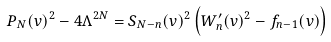<formula> <loc_0><loc_0><loc_500><loc_500>P _ { N } ( v ) ^ { 2 } - 4 \Lambda ^ { 2 N } = S _ { N - n } ( v ) ^ { 2 } \left ( W _ { n } ^ { \prime } ( v ) ^ { 2 } - f _ { n - 1 } ( v ) \right )</formula> 